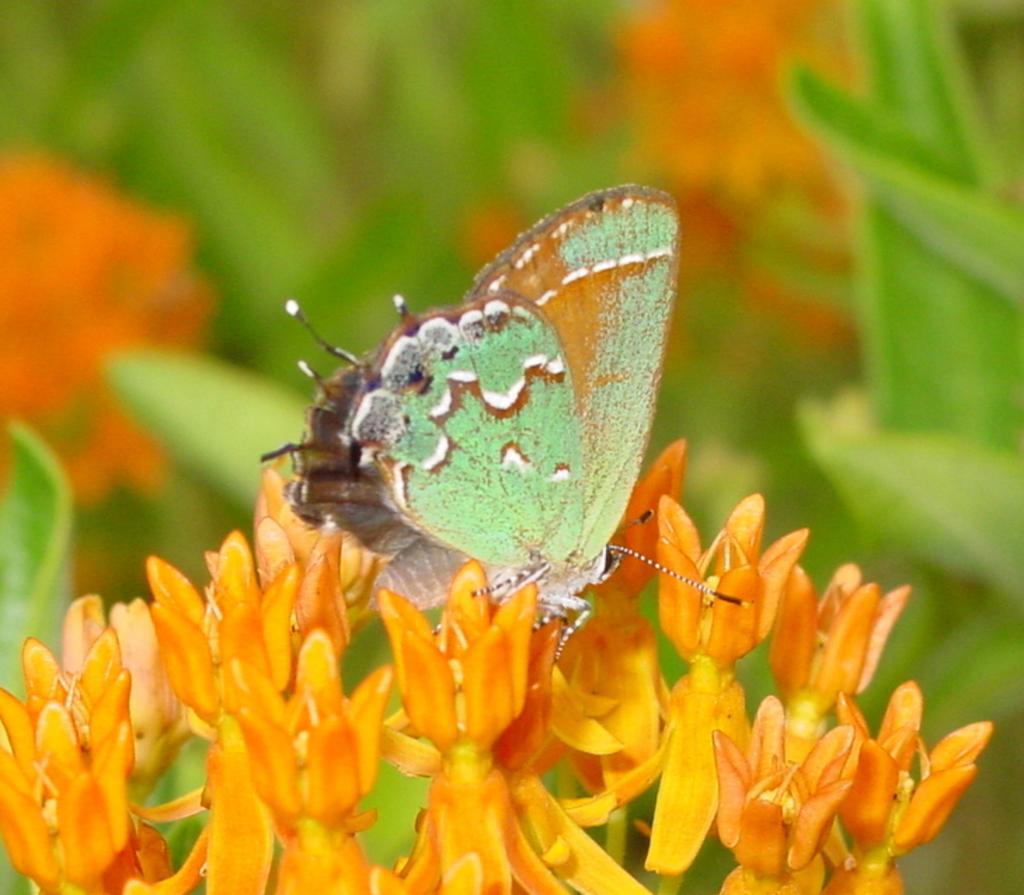What is the main subject of the image? The main subject of the image is a butterfly. Where is the butterfly located in the image? The butterfly is on flowers. Can you describe the background of the image? The background of the image is blurry. What type of picture is hanging on the wall in the image? There is no picture hanging on the wall in the image; it features a butterfly on flowers with a blurry background. 